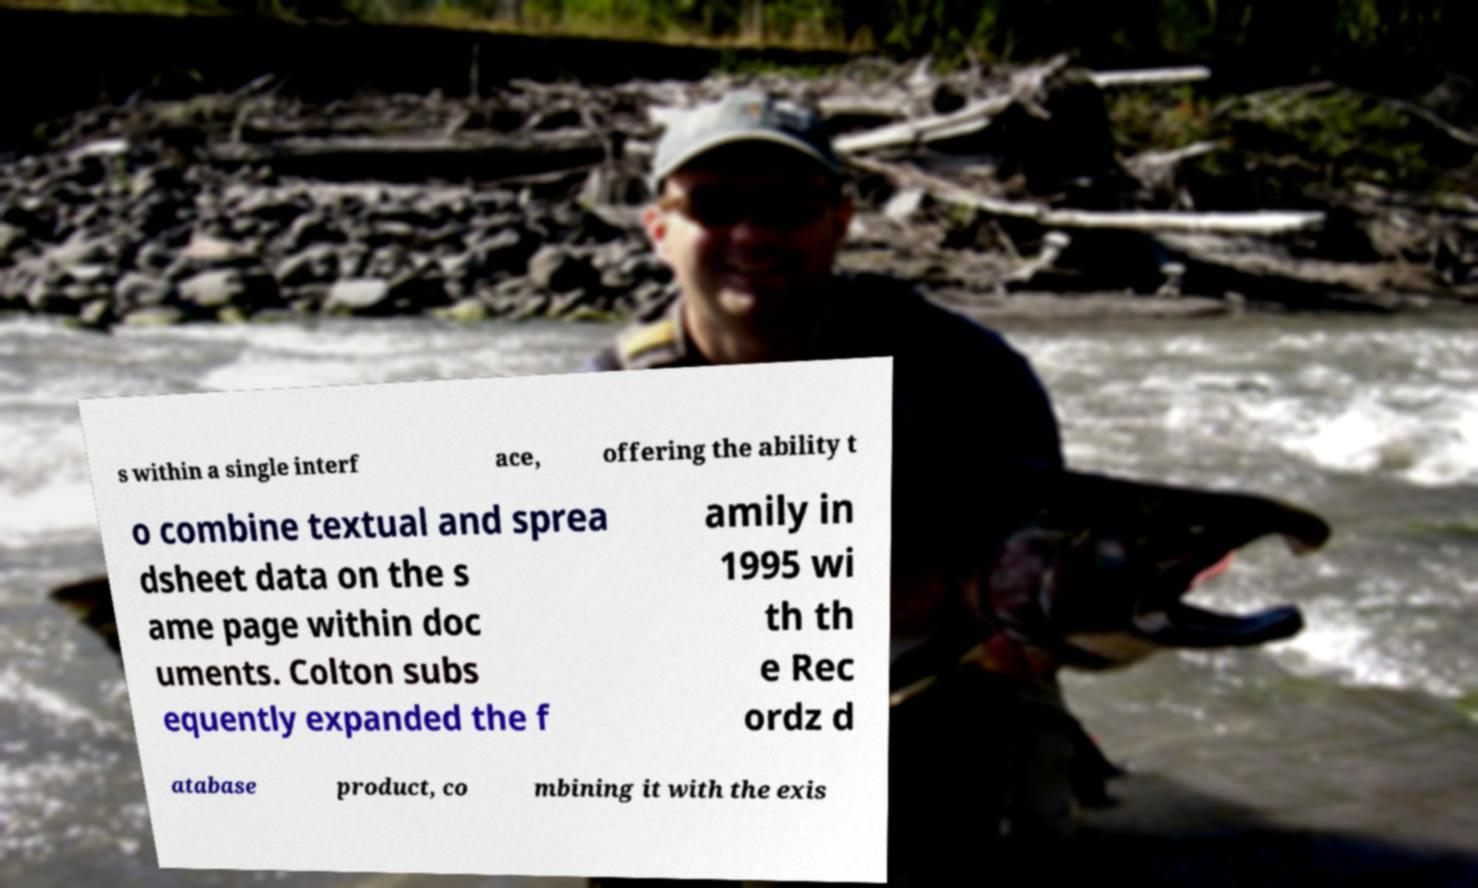Could you extract and type out the text from this image? s within a single interf ace, offering the ability t o combine textual and sprea dsheet data on the s ame page within doc uments. Colton subs equently expanded the f amily in 1995 wi th th e Rec ordz d atabase product, co mbining it with the exis 